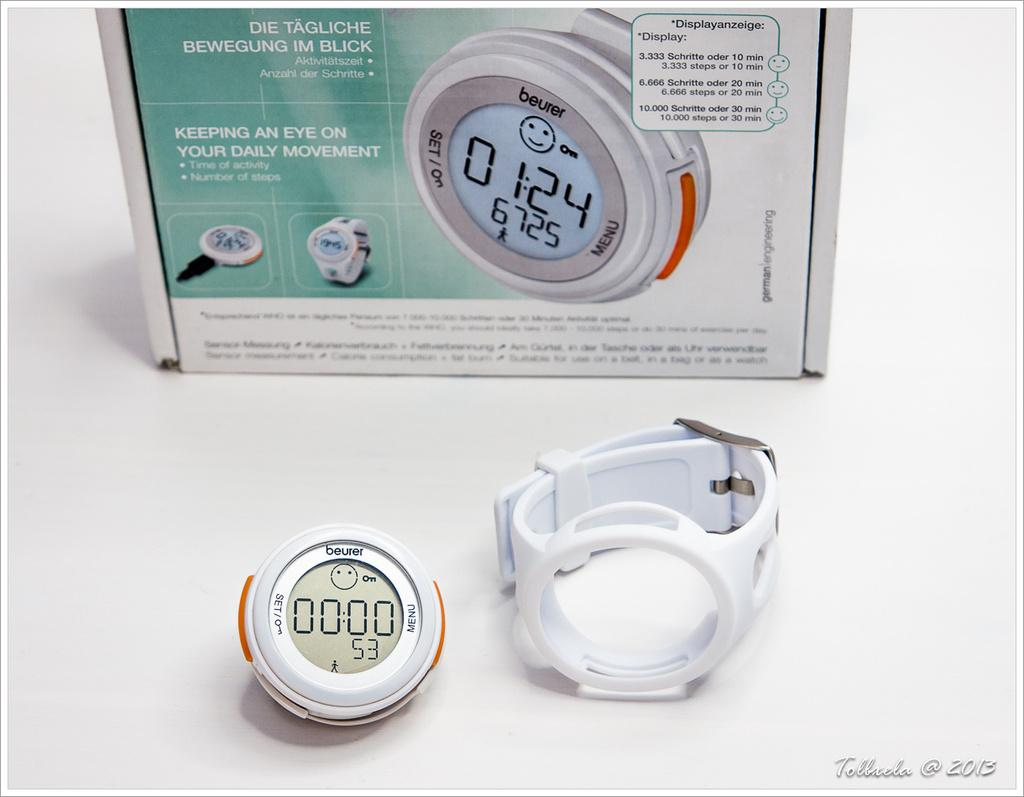Provide a one-sentence caption for the provided image. A pedometer of the brand beurer is sitting in front of the box it came in. 